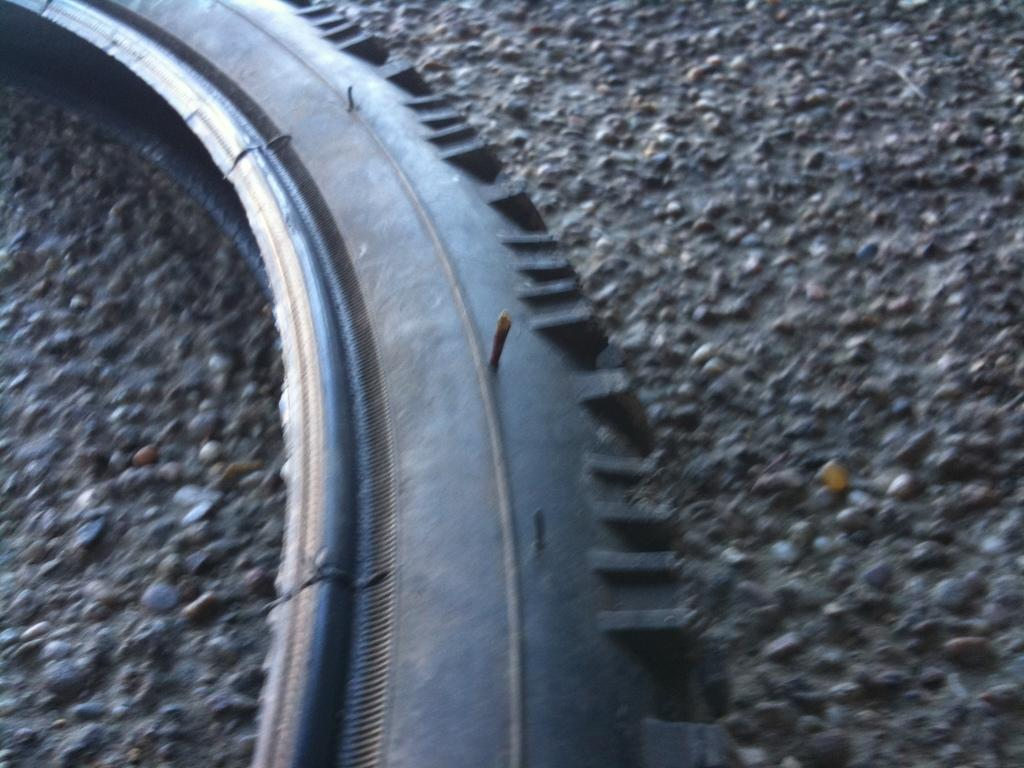What object is present in the image that is typically used for vehicles? There is a tyre in the image. What type of surface is visible at the bottom of the image? There are stones at the bottom of the image. What type of gun can be seen in the image? There is no gun present in the image; it features a tyre and stones. What type of natural disaster is depicted in the image? There is no natural disaster depicted in the image; it features a tyre and stones. 